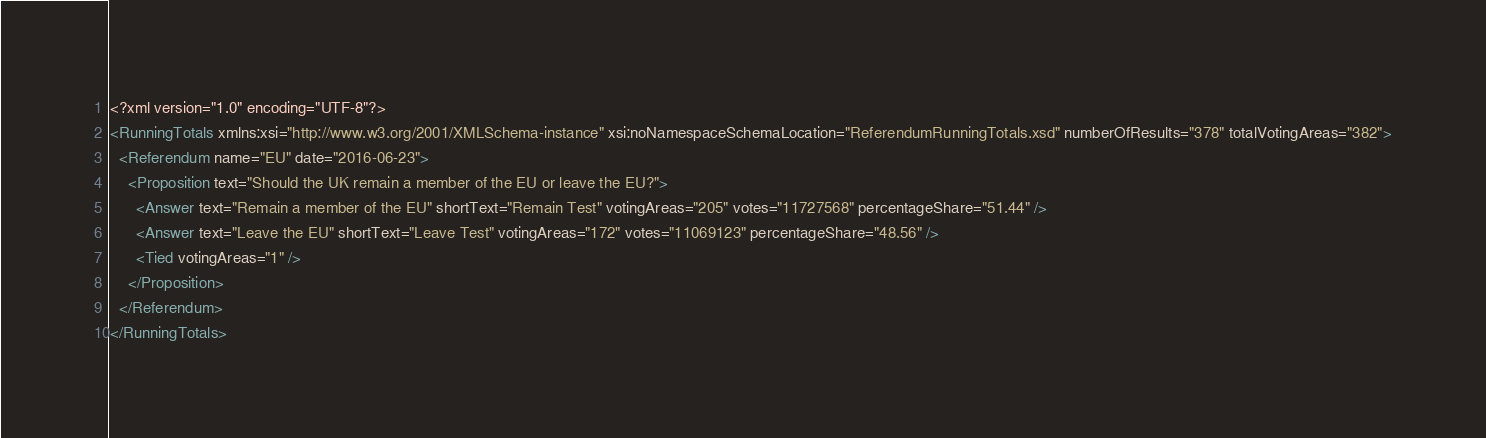<code> <loc_0><loc_0><loc_500><loc_500><_XML_><?xml version="1.0" encoding="UTF-8"?>
<RunningTotals xmlns:xsi="http://www.w3.org/2001/XMLSchema-instance" xsi:noNamespaceSchemaLocation="ReferendumRunningTotals.xsd" numberOfResults="378" totalVotingAreas="382">
  <Referendum name="EU" date="2016-06-23">
    <Proposition text="Should the UK remain a member of the EU or leave the EU?">
      <Answer text="Remain a member of the EU" shortText="Remain Test" votingAreas="205" votes="11727568" percentageShare="51.44" />
      <Answer text="Leave the EU" shortText="Leave Test" votingAreas="172" votes="11069123" percentageShare="48.56" />
      <Tied votingAreas="1" />
    </Proposition>
  </Referendum>
</RunningTotals>

</code> 